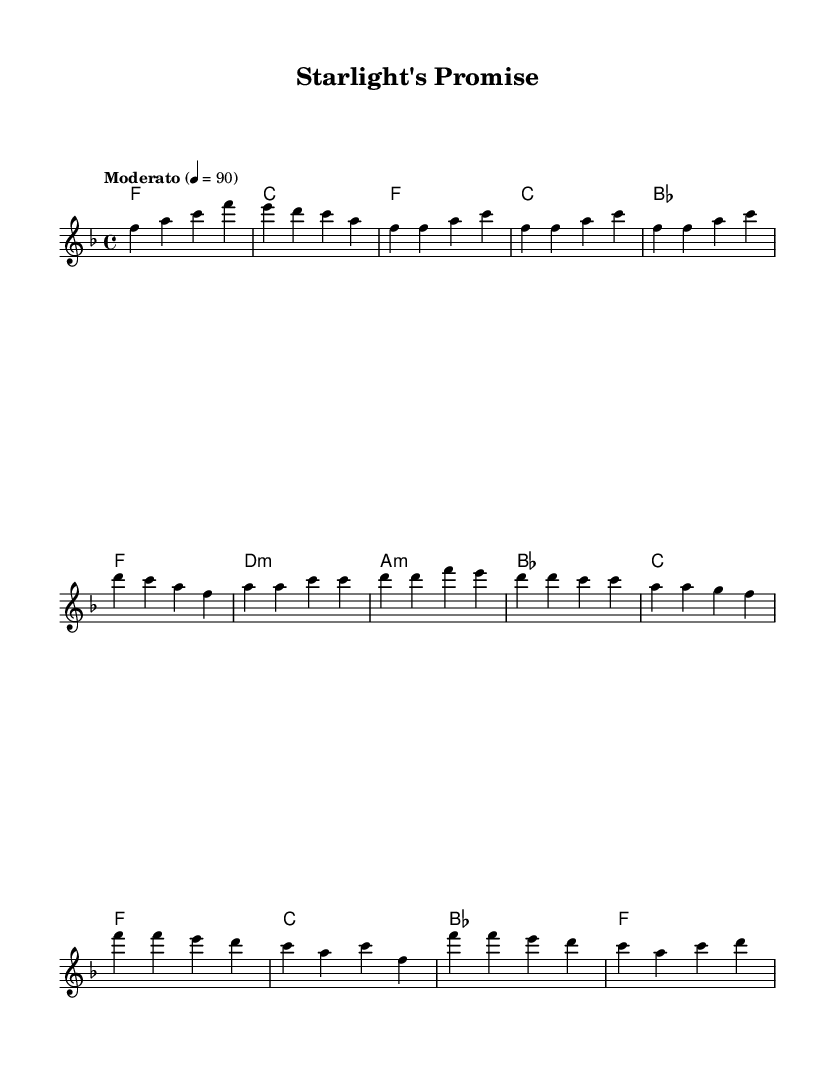What is the key signature of this music? The key signature is F major, which has one flat (B flat). I can tell this from the global section where it specifies \key f \major.
Answer: F major What is the time signature of this music? The time signature is 4/4, as indicated in the global section of the code with \time 4/4. This means there are four beats in each measure.
Answer: 4/4 What is the tempo marking of this piece? The tempo marking is "Moderato" at a speed of 90 beats per minute, which is specified in the global section as \tempo "Moderato" 4 = 90.
Answer: Moderato 90 How many sections are present in the piece? The piece has four main sections: Intro, Verse, Pre-Chorus, and Chorus. This can be determined by observing the breakdown of the melody into these segments.
Answer: Four What are the primary chords used in the Chorus section? The primary chords in the Chorus section are F, C, and B flat, which I can see from the harmonies written for the Chorus. This simple progression contributes to its pop ballad feel.
Answer: F, C, B flat Which voice part is indicated in the score? The indicated voice part in the score is the "lead" voice, which is specified in the new Voice directive as \new Voice = "lead". This identifies which part carries the main melody.
Answer: Lead What is the notation style of the melody in terms of note range? The melody uses a range primarily in the treble clef, mostly centered around the octave of F to F, showing a lyrical and spacious style typical for pop ballads. This can be understood by analyzing the notes written.
Answer: Treble clef 